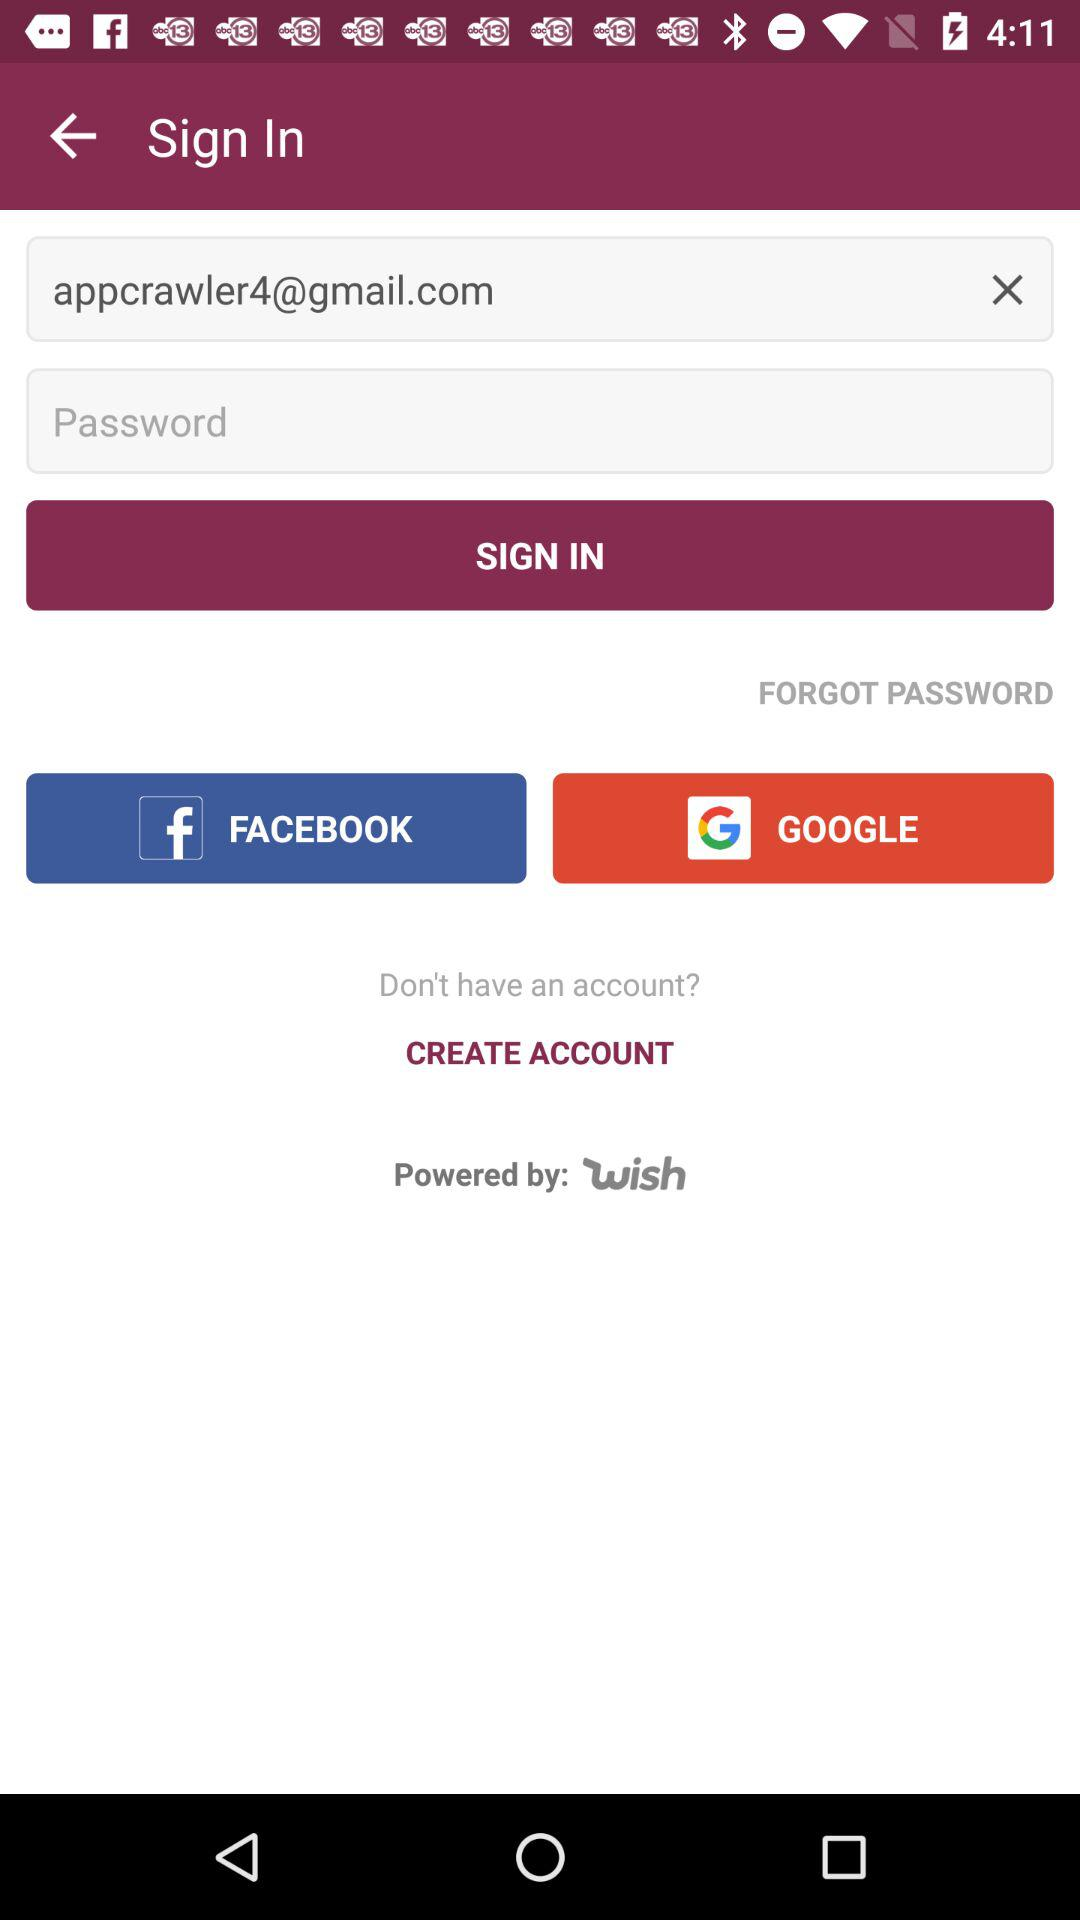What are the requirements to get a login?
When the provided information is insufficient, respond with <no answer>. <no answer> 